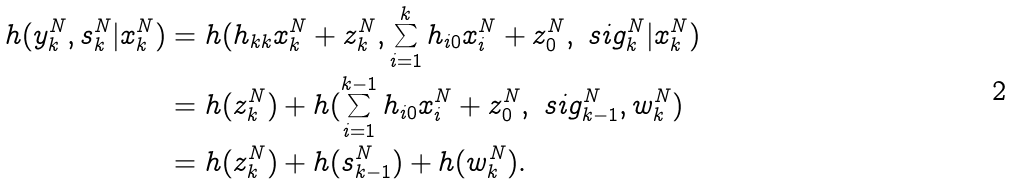<formula> <loc_0><loc_0><loc_500><loc_500>h ( y _ { k } ^ { N } , s _ { k } ^ { N } | x _ { k } ^ { N } ) & = h ( h _ { k k } x _ { k } ^ { N } + z _ { k } ^ { N } , \sum _ { i = 1 } ^ { k } h _ { i 0 } x _ { i } ^ { N } + z _ { 0 } ^ { N } , \ s i g _ { k } ^ { N } | x _ { k } ^ { N } ) \\ & = h ( z _ { k } ^ { N } ) + h ( \sum _ { i = 1 } ^ { k - 1 } h _ { i 0 } x _ { i } ^ { N } + z _ { 0 } ^ { N } , \ s i g ^ { N } _ { k - 1 } , w _ { k } ^ { N } ) \\ & = h ( z _ { k } ^ { N } ) + h ( s _ { k - 1 } ^ { N } ) + h ( w _ { k } ^ { N } ) .</formula> 